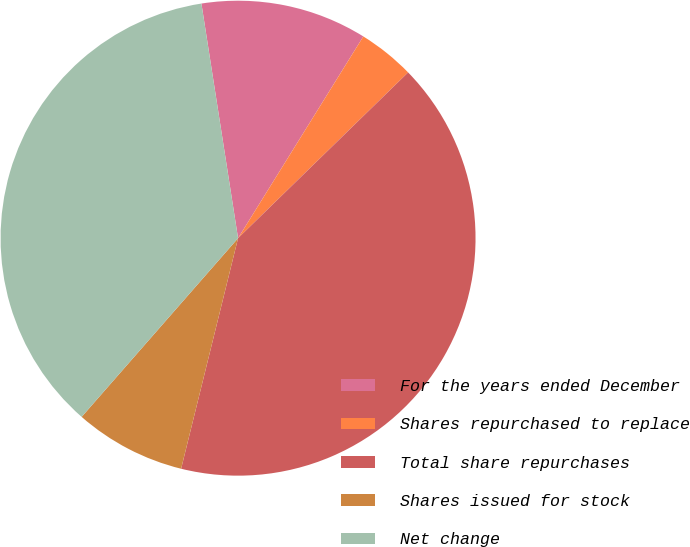Convert chart to OTSL. <chart><loc_0><loc_0><loc_500><loc_500><pie_chart><fcel>For the years ended December<fcel>Shares repurchased to replace<fcel>Total share repurchases<fcel>Shares issued for stock<fcel>Net change<nl><fcel>11.31%<fcel>3.86%<fcel>41.15%<fcel>7.59%<fcel>36.09%<nl></chart> 